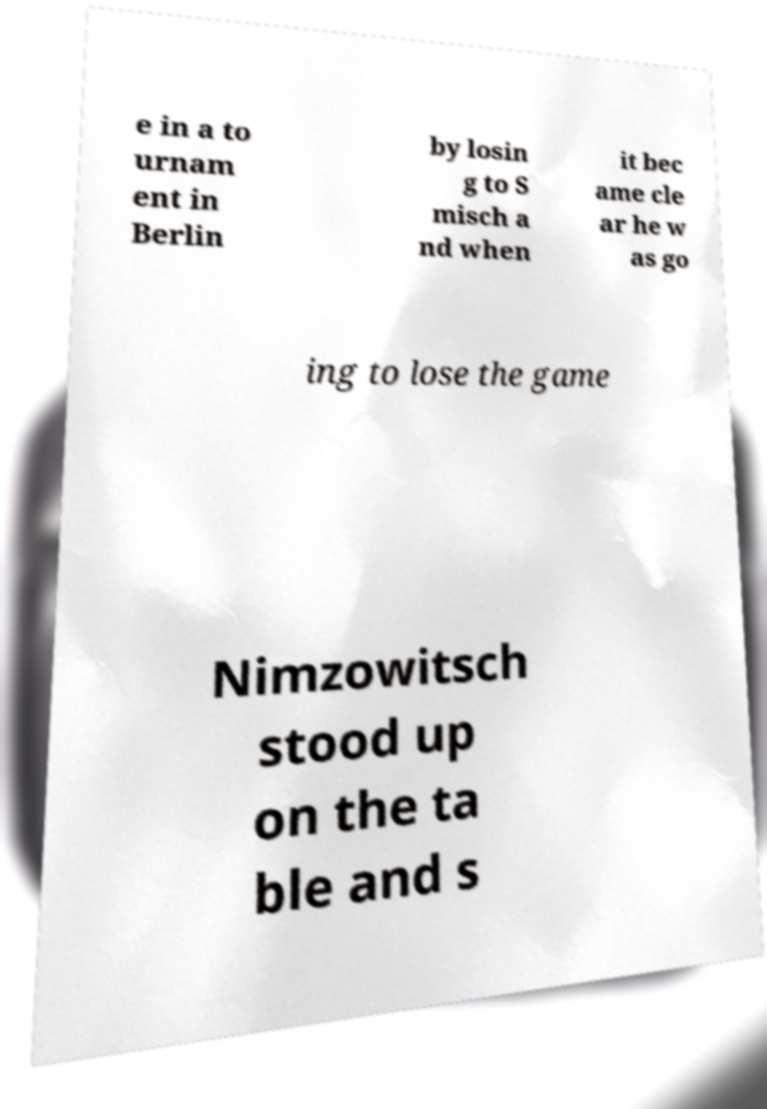There's text embedded in this image that I need extracted. Can you transcribe it verbatim? e in a to urnam ent in Berlin by losin g to S misch a nd when it bec ame cle ar he w as go ing to lose the game Nimzowitsch stood up on the ta ble and s 